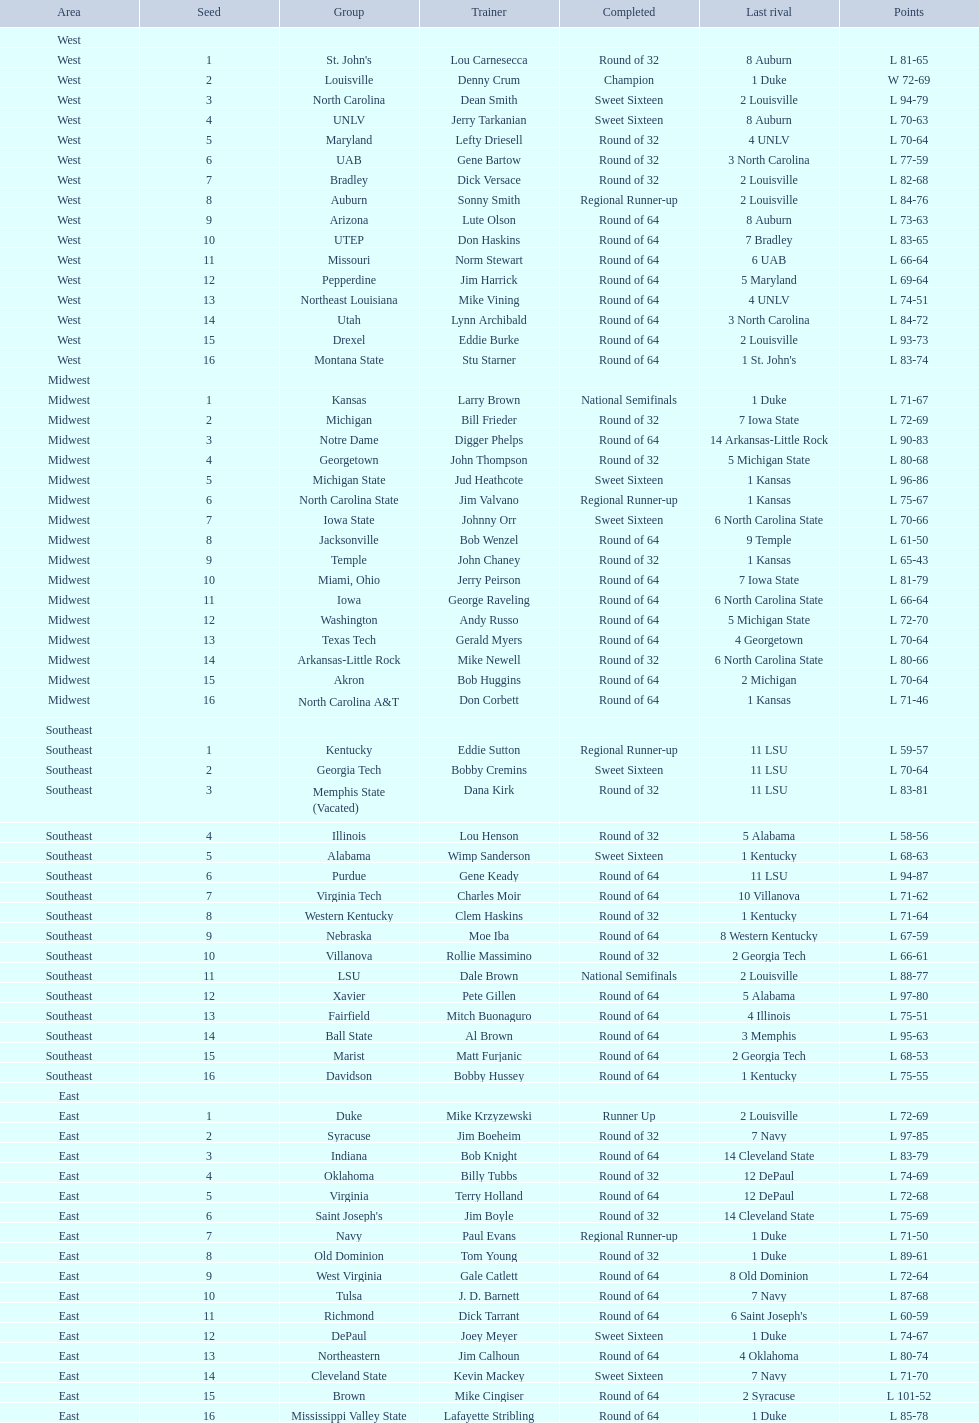How many teams were involved in the play? 64. 